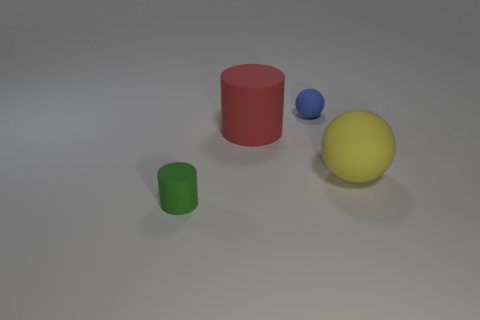Add 4 big cyan balls. How many objects exist? 8 Subtract 1 balls. How many balls are left? 1 Subtract all red cylinders. How many purple spheres are left? 0 Add 3 big blue metallic cylinders. How many big blue metallic cylinders exist? 3 Subtract 0 blue cylinders. How many objects are left? 4 Subtract all yellow cylinders. Subtract all brown cubes. How many cylinders are left? 2 Subtract all spheres. Subtract all big balls. How many objects are left? 1 Add 1 blue matte objects. How many blue matte objects are left? 2 